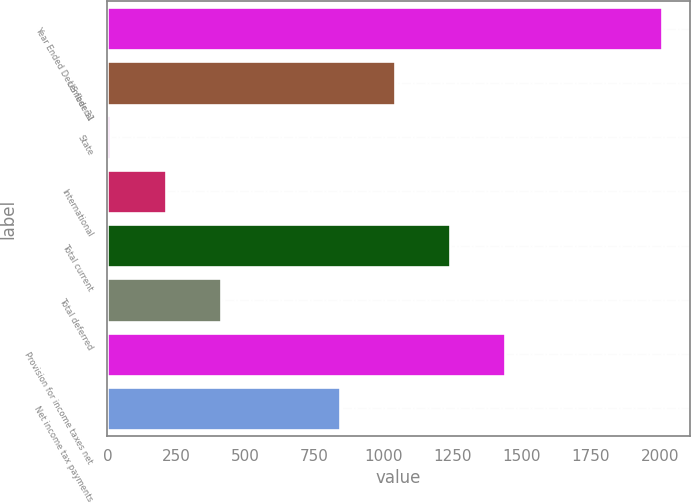Convert chart. <chart><loc_0><loc_0><loc_500><loc_500><bar_chart><fcel>Year Ended December 31<fcel>US federal<fcel>State<fcel>International<fcel>Total current<fcel>Total deferred<fcel>Provision for income taxes net<fcel>Net income tax payments<nl><fcel>2008<fcel>1040.7<fcel>11<fcel>210.7<fcel>1240.4<fcel>410.4<fcel>1440.1<fcel>841<nl></chart> 